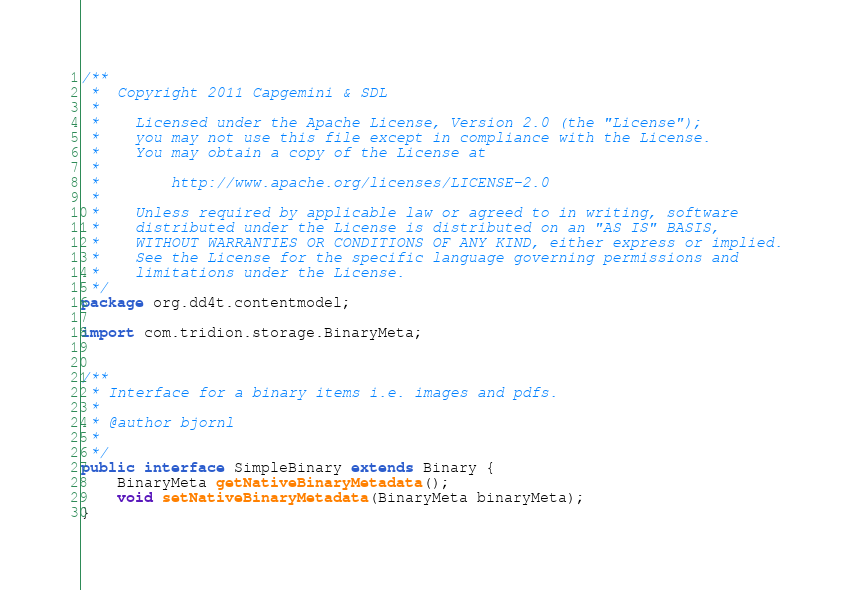<code> <loc_0><loc_0><loc_500><loc_500><_Java_>/**  
 *  Copyright 2011 Capgemini & SDL
 * 
 *    Licensed under the Apache License, Version 2.0 (the "License");
 *    you may not use this file except in compliance with the License.
 *    You may obtain a copy of the License at
 * 
 *        http://www.apache.org/licenses/LICENSE-2.0
 * 
 *    Unless required by applicable law or agreed to in writing, software
 *    distributed under the License is distributed on an "AS IS" BASIS,
 *    WITHOUT WARRANTIES OR CONDITIONS OF ANY KIND, either express or implied.
 *    See the License for the specific language governing permissions and
 *    limitations under the License.
 */
package org.dd4t.contentmodel;

import com.tridion.storage.BinaryMeta;


/**
 * Interface for a binary items i.e. images and pdfs.
 * 
 * @author bjornl
 * 
 */
public interface SimpleBinary extends Binary {
	BinaryMeta getNativeBinaryMetadata();
	void setNativeBinaryMetadata(BinaryMeta binaryMeta);
}
</code> 